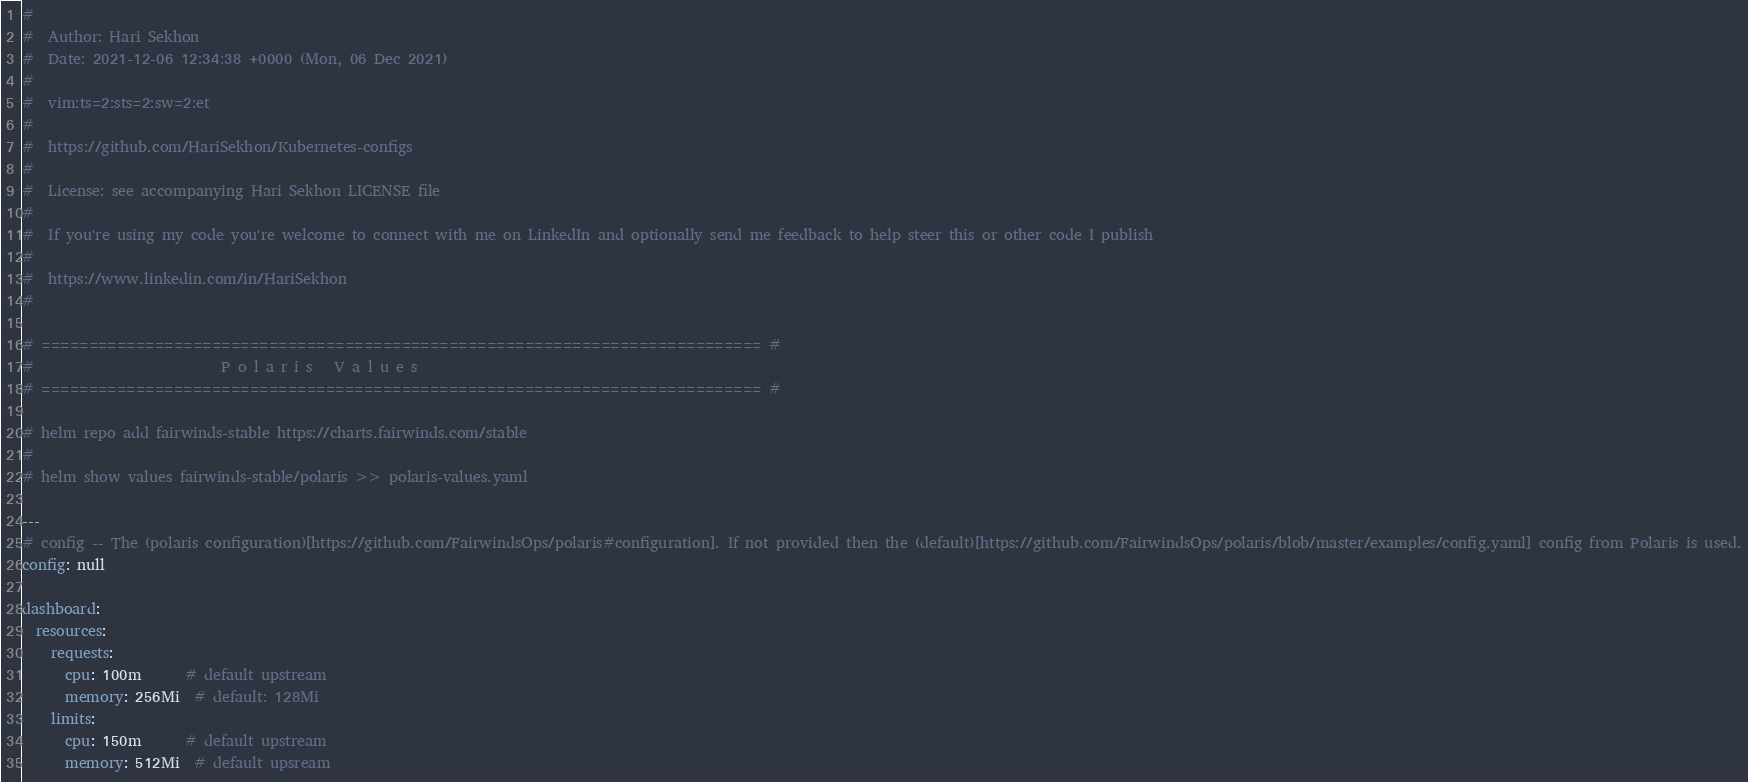<code> <loc_0><loc_0><loc_500><loc_500><_YAML_>#
#  Author: Hari Sekhon
#  Date: 2021-12-06 12:34:38 +0000 (Mon, 06 Dec 2021)
#
#  vim:ts=2:sts=2:sw=2:et
#
#  https://github.com/HariSekhon/Kubernetes-configs
#
#  License: see accompanying Hari Sekhon LICENSE file
#
#  If you're using my code you're welcome to connect with me on LinkedIn and optionally send me feedback to help steer this or other code I publish
#
#  https://www.linkedin.com/in/HariSekhon
#

# ============================================================================ #
#                          P o l a r i s   V a l u e s
# ============================================================================ #

# helm repo add fairwinds-stable https://charts.fairwinds.com/stable
#
# helm show values fairwinds-stable/polaris >> polaris-values.yaml

---
# config -- The (polaris configuration)[https://github.com/FairwindsOps/polaris#configuration]. If not provided then the (default)[https://github.com/FairwindsOps/polaris/blob/master/examples/config.yaml] config from Polaris is used.
config: null

dashboard:
  resources:
    requests:
      cpu: 100m      # default upstream
      memory: 256Mi  # default: 128Mi
    limits:
      cpu: 150m      # default upstream
      memory: 512Mi  # default upsream
</code> 